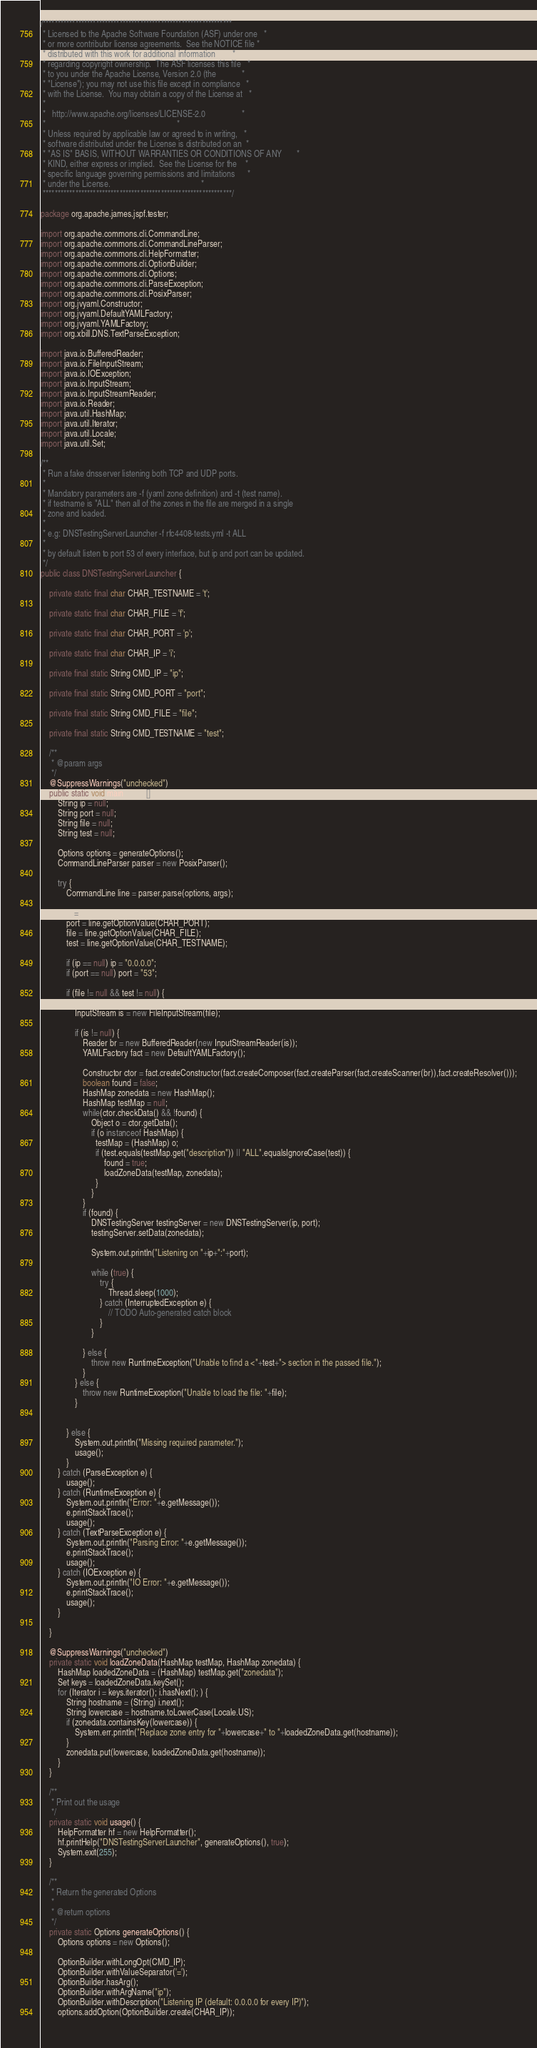<code> <loc_0><loc_0><loc_500><loc_500><_Java_>/****************************************************************
 * Licensed to the Apache Software Foundation (ASF) under one   *
 * or more contributor license agreements.  See the NOTICE file *
 * distributed with this work for additional information        *
 * regarding copyright ownership.  The ASF licenses this file   *
 * to you under the Apache License, Version 2.0 (the            *
 * "License"); you may not use this file except in compliance   *
 * with the License.  You may obtain a copy of the License at   *
 *                                                              *
 *   http://www.apache.org/licenses/LICENSE-2.0                 *
 *                                                              *
 * Unless required by applicable law or agreed to in writing,   *
 * software distributed under the License is distributed on an  *
 * "AS IS" BASIS, WITHOUT WARRANTIES OR CONDITIONS OF ANY       *
 * KIND, either express or implied.  See the License for the    *
 * specific language governing permissions and limitations      *
 * under the License.                                           *
 ****************************************************************/

package org.apache.james.jspf.tester;

import org.apache.commons.cli.CommandLine;
import org.apache.commons.cli.CommandLineParser;
import org.apache.commons.cli.HelpFormatter;
import org.apache.commons.cli.OptionBuilder;
import org.apache.commons.cli.Options;
import org.apache.commons.cli.ParseException;
import org.apache.commons.cli.PosixParser;
import org.jvyaml.Constructor;
import org.jvyaml.DefaultYAMLFactory;
import org.jvyaml.YAMLFactory;
import org.xbill.DNS.TextParseException;

import java.io.BufferedReader;
import java.io.FileInputStream;
import java.io.IOException;
import java.io.InputStream;
import java.io.InputStreamReader;
import java.io.Reader;
import java.util.HashMap;
import java.util.Iterator;
import java.util.Locale;
import java.util.Set;

/**
 * Run a fake dnsserver listening both TCP and UDP ports.
 * 
 * Mandatory parameters are -f (yaml zone definition) and -t (test name).
 * if testname is "ALL" then all of the zones in the file are merged in a single
 * zone and loaded.
 * 
 * e.g: DNSTestingServerLauncher -f rfc4408-tests.yml -t ALL
 * 
 * by default listen to port 53 of every interface, but ip and port can be updated.
 */
public class DNSTestingServerLauncher {

    private static final char CHAR_TESTNAME = 't';

    private static final char CHAR_FILE = 'f';

    private static final char CHAR_PORT = 'p';

    private static final char CHAR_IP = 'i';

    private final static String CMD_IP = "ip";

    private final static String CMD_PORT = "port";

    private final static String CMD_FILE = "file";

    private final static String CMD_TESTNAME = "test";

    /**
     * @param args
     */
    @SuppressWarnings("unchecked")
    public static void main(String[] args) {
        String ip = null;
        String port = null;
        String file = null;
        String test = null;
        
        Options options = generateOptions();
        CommandLineParser parser = new PosixParser();

        try {
            CommandLine line = parser.parse(options, args);
            
            ip = line.getOptionValue(CHAR_IP);
            port = line.getOptionValue(CHAR_PORT);
            file = line.getOptionValue(CHAR_FILE);
            test = line.getOptionValue(CHAR_TESTNAME);
            
            if (ip == null) ip = "0.0.0.0";
            if (port == null) port = "53";
            
            if (file != null && test != null) {
                
                InputStream is = new FileInputStream(file);
                
                if (is != null) {
                    Reader br = new BufferedReader(new InputStreamReader(is));
                    YAMLFactory fact = new DefaultYAMLFactory();
                    
                    Constructor ctor = fact.createConstructor(fact.createComposer(fact.createParser(fact.createScanner(br)),fact.createResolver()));
                    boolean found = false;
                    HashMap zonedata = new HashMap();
                    HashMap testMap = null;
                    while(ctor.checkData() && !found) {
                        Object o = ctor.getData();
                        if (o instanceof HashMap) {
                          testMap = (HashMap) o;
                          if (test.equals(testMap.get("description")) || "ALL".equalsIgnoreCase(test)) {
                              found = true;
                              loadZoneData(testMap, zonedata);
                          }
                        }
                    }
                    if (found) {
                        DNSTestingServer testingServer = new DNSTestingServer(ip, port);
                        testingServer.setData(zonedata);
                        
                        System.out.println("Listening on "+ip+":"+port);
                        
                        while (true) {
                            try {
                                Thread.sleep(1000);
                            } catch (InterruptedException e) {
                                // TODO Auto-generated catch block
                            }
                        }
                        
                    } else {
                        throw new RuntimeException("Unable to find a <"+test+"> section in the passed file.");
                    }
                } else {
                    throw new RuntimeException("Unable to load the file: "+file);
                }

                
            } else {
                System.out.println("Missing required parameter.");
                usage();
            }
        } catch (ParseException e) {
            usage();
        } catch (RuntimeException e) {
            System.out.println("Error: "+e.getMessage());
            e.printStackTrace();
            usage();
        } catch (TextParseException e) {
            System.out.println("Parsing Error: "+e.getMessage());
            e.printStackTrace();
            usage();
        } catch (IOException e) {
            System.out.println("IO Error: "+e.getMessage());
            e.printStackTrace();
            usage();
        }

    }

    @SuppressWarnings("unchecked")
    private static void loadZoneData(HashMap testMap, HashMap zonedata) {
        HashMap loadedZoneData = (HashMap) testMap.get("zonedata");
        Set keys = loadedZoneData.keySet();
        for (Iterator i = keys.iterator(); i.hasNext(); ) {
            String hostname = (String) i.next();
            String lowercase = hostname.toLowerCase(Locale.US);
            if (zonedata.containsKey(lowercase)) {
                System.err.println("Replace zone entry for "+lowercase+" to "+loadedZoneData.get(hostname));
            }
            zonedata.put(lowercase, loadedZoneData.get(hostname));
        }
    }

    /**
     * Print out the usage
     */
    private static void usage() {
        HelpFormatter hf = new HelpFormatter();
        hf.printHelp("DNSTestingServerLauncher", generateOptions(), true);
        System.exit(255);
    }

    /**
     * Return the generated Options
     * 
     * @return options
     */
    private static Options generateOptions() {
        Options options = new Options();
        
        OptionBuilder.withLongOpt(CMD_IP);
        OptionBuilder.withValueSeparator('=');
        OptionBuilder.hasArg();
        OptionBuilder.withArgName("ip");
        OptionBuilder.withDescription("Listening IP (default: 0.0.0.0 for every IP)");
        options.addOption(OptionBuilder.create(CHAR_IP));
                </code> 